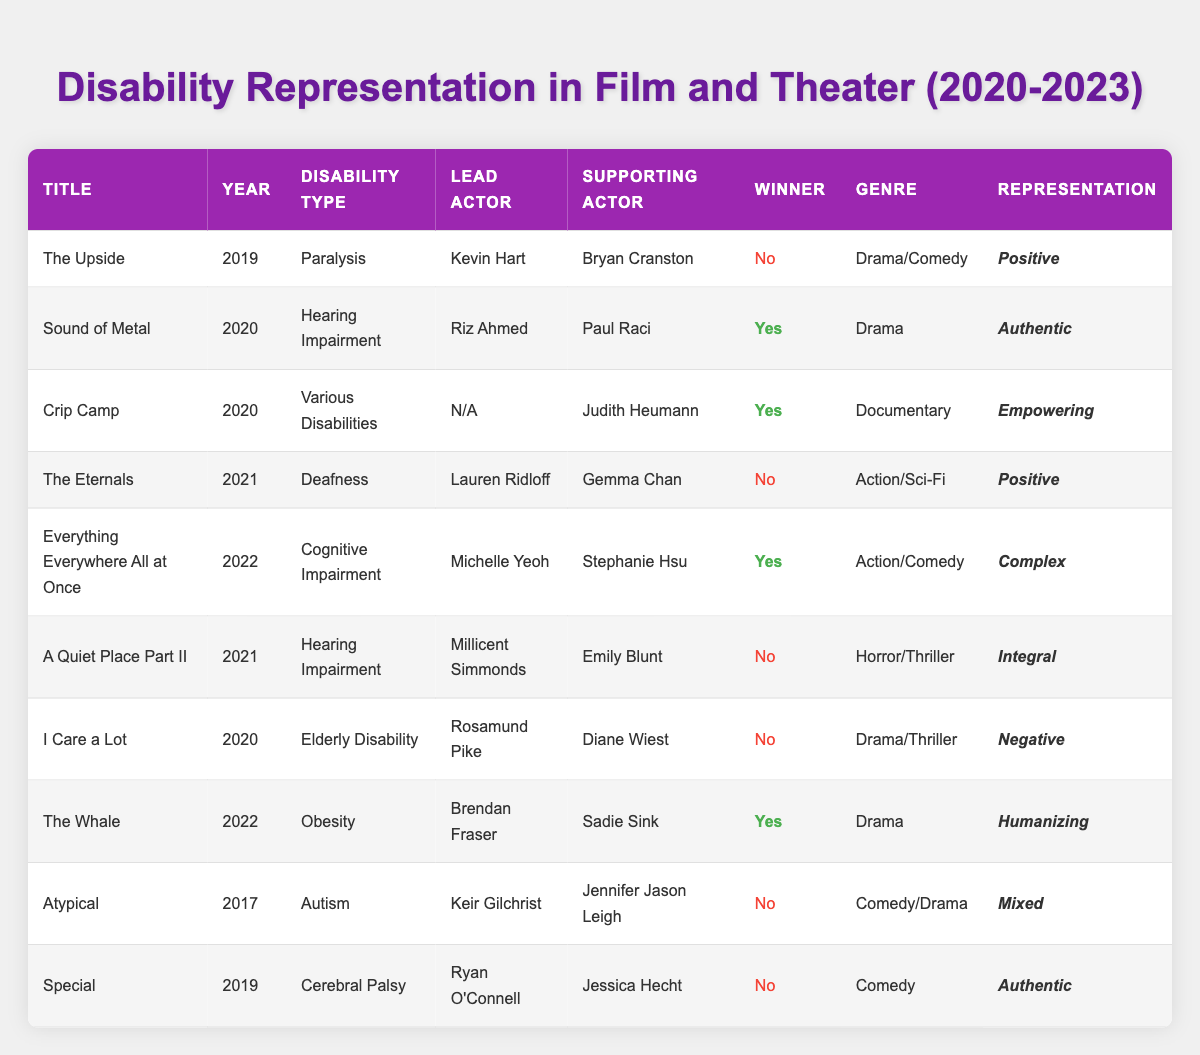What is the title of the movie released in 2020 that features a lead actor with hearing impairment? From the table, I can see that "Sound of Metal" is listed under the year 2020 and features Riz Ahmed as the lead actor with a disability of hearing impairment.
Answer: Sound of Metal Which film released in 2022 has a representation categorized as "Humanizing"? The film "The Whale," released in 2022, has the representation type listed as "Humanizing."
Answer: The Whale How many different disability types are represented among the listed films from 2020 to 2023? The table includes the following unique disability types: Hearing Impairment, Various Disabilities, Deafness, Cognitive Impairment, Elderly Disability, and Obesity. Counting them gives a total of 6 different disability types.
Answer: 6 Was the lead actor of "A Quiet Place Part II" a winner? In the table, "A Quiet Place Part II" is marked as a non-winner, which indicates that there was no award associated with it.
Answer: No Which movie with a supporting actor was recognized as a winner and is categorized as a documentary? The movie "Crip Camp" features Judith Heumann as the supporting actor and is marked as a winner with the genre "Documentary."
Answer: Crip Camp What percentage of the films listed won awards? There are 10 total films listed, and 4 of them have won awards. To find the percentage, calculate (4/10) * 100 = 40%.
Answer: 40% Among the films from 2020 to 2023, how many have a positive representation? By examining the table, I see that "Sound of Metal," "The Eternals," and "The Upside" are marked with positive representation. This totals to 3 films.
Answer: 3 Is it true that the lead actor in "Everything Everywhere All at Once" has a cognitive impairment disability? The table indicates that the film "Everything Everywhere All at Once" has a lead actor, Michelle Yeoh, who portrays a character with cognitive impairment as per the listed disability type.
Answer: Yes What is the genre of the film "I Care a Lot"? According to the table, "I Care a Lot" falls under the genre of Drama/Thriller.
Answer: Drama/Thriller 